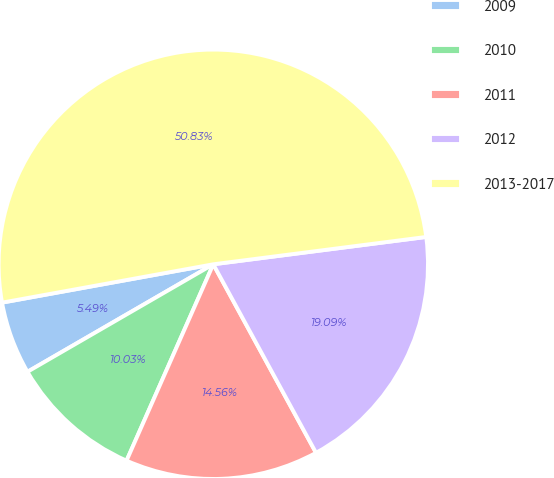Convert chart to OTSL. <chart><loc_0><loc_0><loc_500><loc_500><pie_chart><fcel>2009<fcel>2010<fcel>2011<fcel>2012<fcel>2013-2017<nl><fcel>5.49%<fcel>10.03%<fcel>14.56%<fcel>19.09%<fcel>50.82%<nl></chart> 